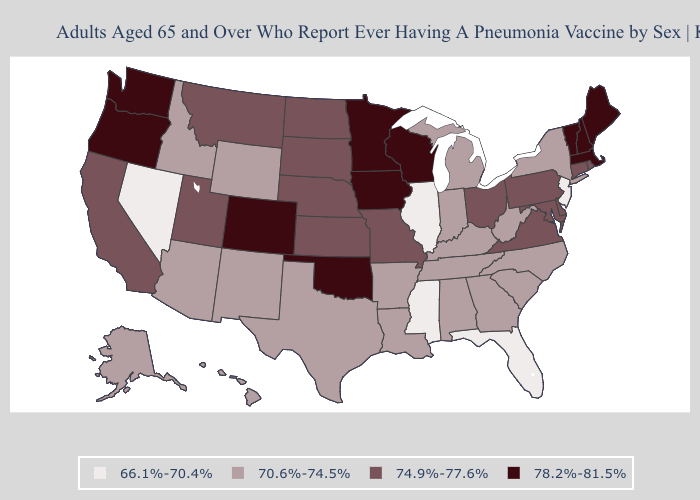What is the value of Wyoming?
Quick response, please. 70.6%-74.5%. Does Georgia have the same value as Nevada?
Concise answer only. No. Among the states that border Idaho , does Montana have the highest value?
Answer briefly. No. What is the value of Idaho?
Concise answer only. 70.6%-74.5%. Does Illinois have the highest value in the MidWest?
Keep it brief. No. Name the states that have a value in the range 66.1%-70.4%?
Write a very short answer. Florida, Illinois, Mississippi, Nevada, New Jersey. Does the map have missing data?
Quick response, please. No. Which states have the lowest value in the West?
Be succinct. Nevada. Does Maine have the highest value in the USA?
Short answer required. Yes. What is the value of Delaware?
Keep it brief. 74.9%-77.6%. Does South Dakota have a higher value than Hawaii?
Answer briefly. Yes. What is the value of Ohio?
Short answer required. 74.9%-77.6%. Name the states that have a value in the range 74.9%-77.6%?
Concise answer only. California, Connecticut, Delaware, Kansas, Maryland, Missouri, Montana, Nebraska, North Dakota, Ohio, Pennsylvania, Rhode Island, South Dakota, Utah, Virginia. Which states have the highest value in the USA?
Short answer required. Colorado, Iowa, Maine, Massachusetts, Minnesota, New Hampshire, Oklahoma, Oregon, Vermont, Washington, Wisconsin. What is the value of New Mexico?
Short answer required. 70.6%-74.5%. 